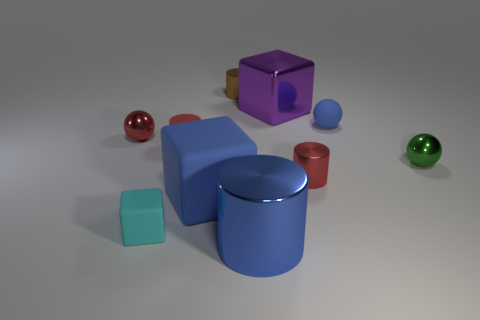Subtract all big cubes. How many cubes are left? 1 Subtract all red balls. How many balls are left? 2 Subtract all cylinders. How many objects are left? 6 Subtract all blue spheres. How many red cylinders are left? 2 Add 3 tiny balls. How many tiny balls exist? 6 Subtract 0 brown spheres. How many objects are left? 10 Subtract 1 cylinders. How many cylinders are left? 3 Subtract all purple cubes. Subtract all blue cylinders. How many cubes are left? 2 Subtract all large gray balls. Subtract all large metal cubes. How many objects are left? 9 Add 8 cyan rubber objects. How many cyan rubber objects are left? 9 